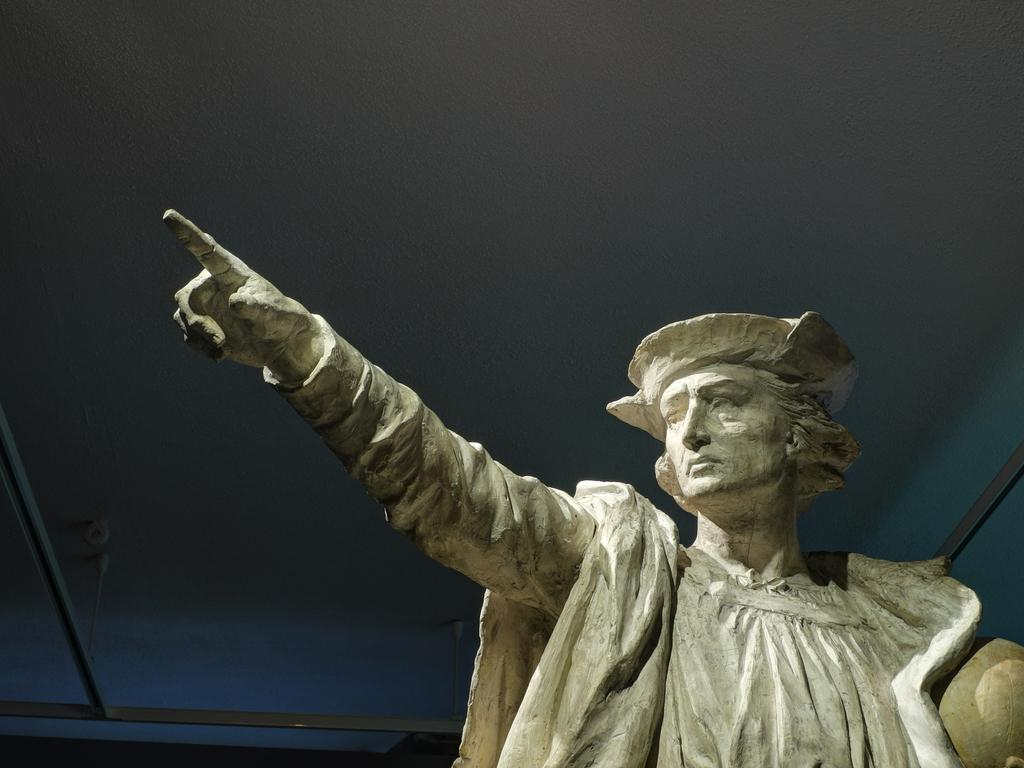What is the main subject in the center of the image? There is a statue in the center of the image. What can be seen in the background of the image? There is a wall in the background of the image. Are there any other objects visible in the background? Yes, there are a few other objects in the background of the image. What type of engine is visible in the image? There is no engine present in the image; it features a statue and a wall in the background. Can you tell me how many rings are on the statue's finger in the image? There are no rings visible on the statue's finger in the image, as it is a statue and not a person. 